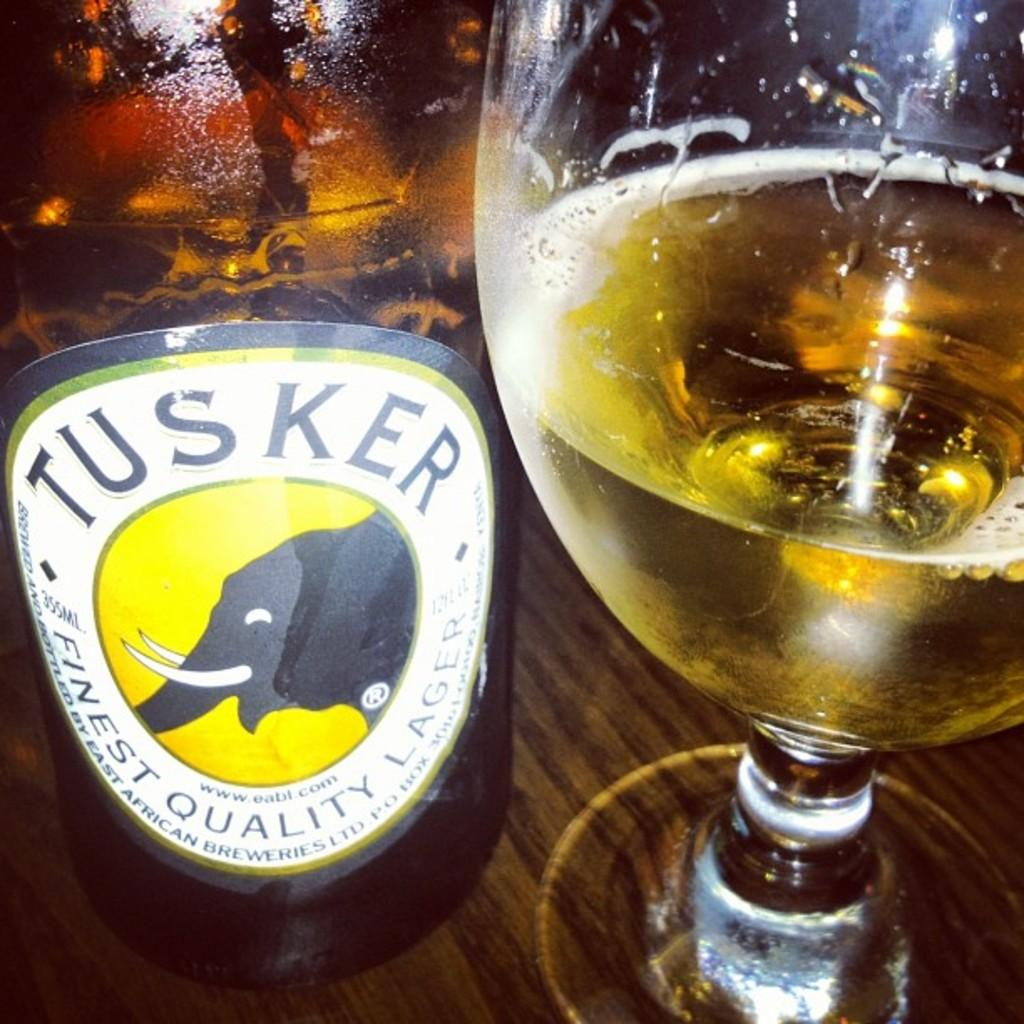<image>
Describe the image concisely. A 1/3 full brandy snifter next to a bottle of Tusker Finest Quality Lager. 